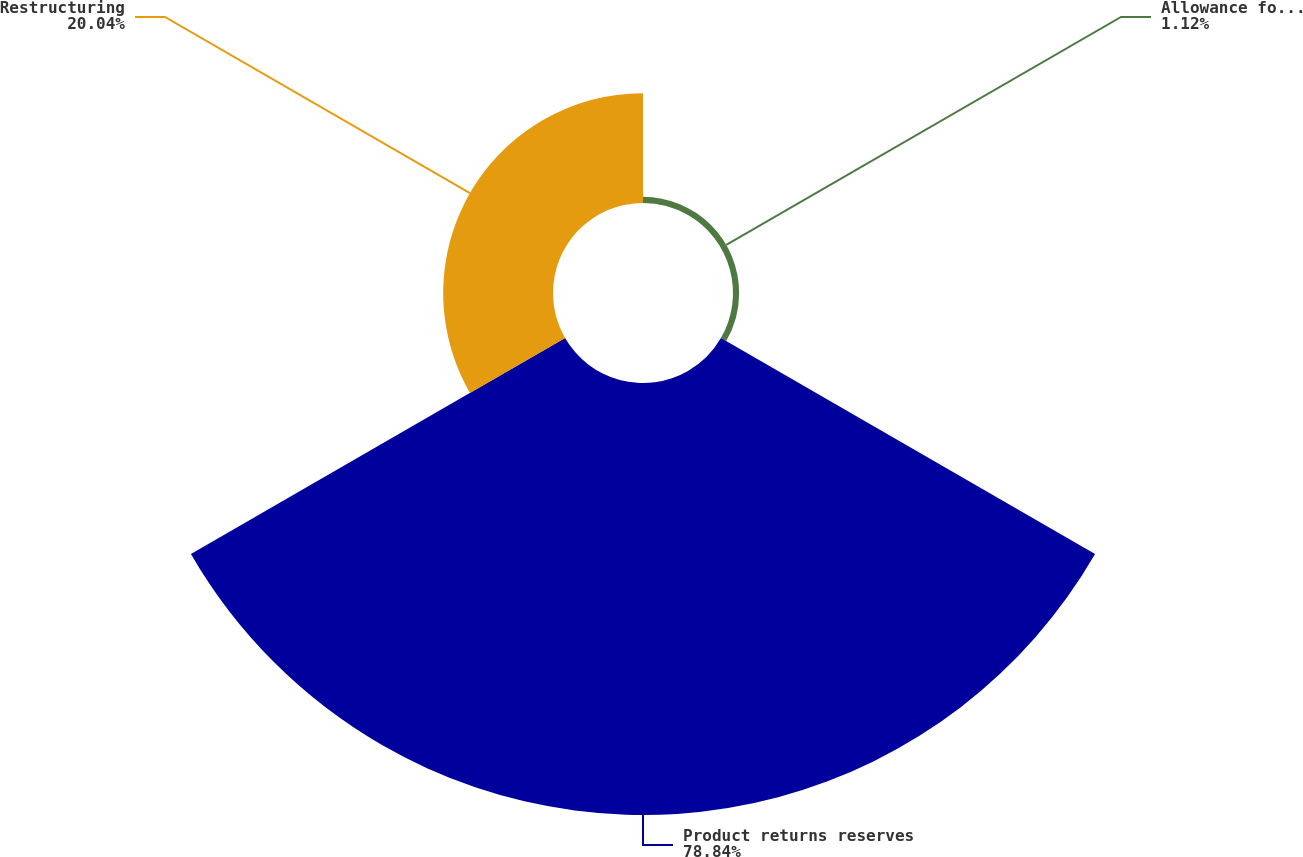Convert chart to OTSL. <chart><loc_0><loc_0><loc_500><loc_500><pie_chart><fcel>Allowance for doubtful<fcel>Product returns reserves<fcel>Restructuring<nl><fcel>1.12%<fcel>78.84%<fcel>20.04%<nl></chart> 